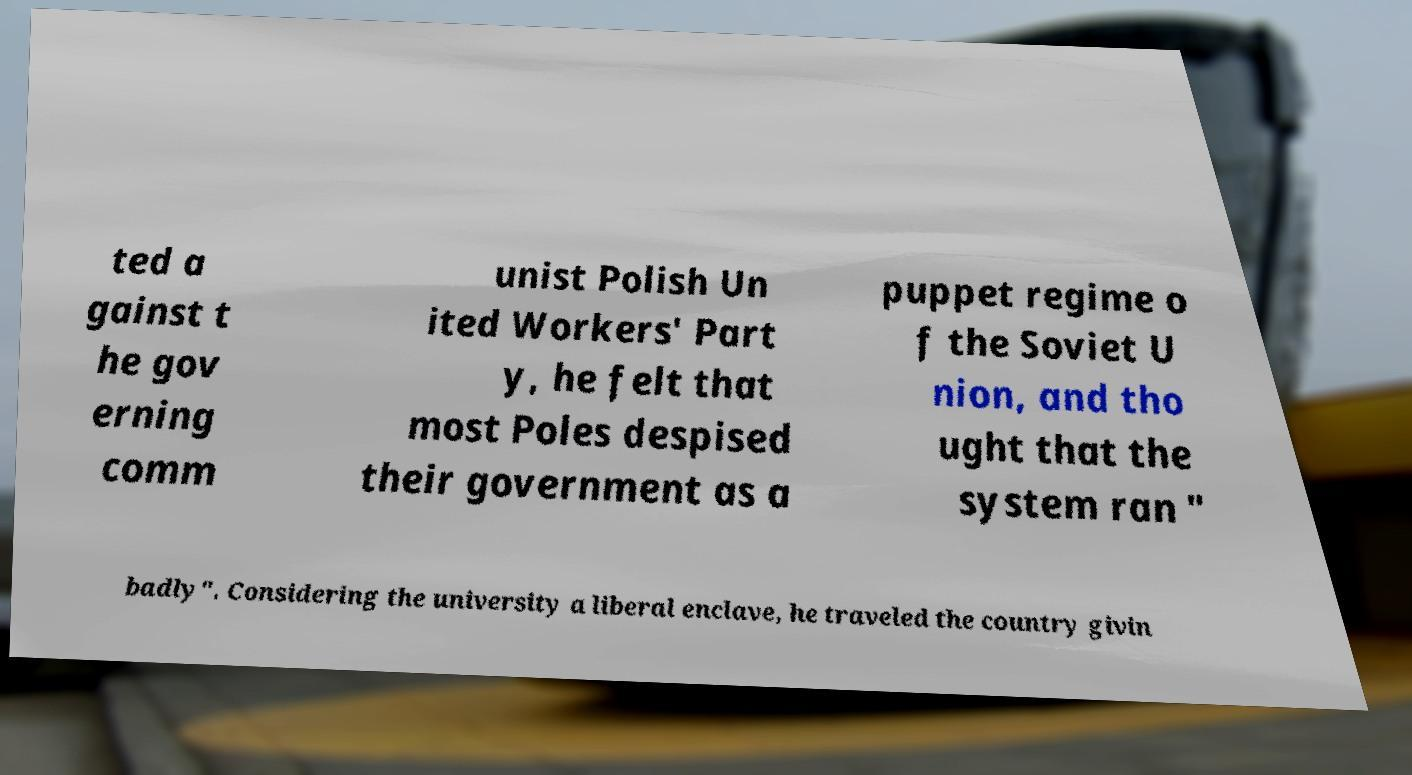There's text embedded in this image that I need extracted. Can you transcribe it verbatim? ted a gainst t he gov erning comm unist Polish Un ited Workers' Part y, he felt that most Poles despised their government as a puppet regime o f the Soviet U nion, and tho ught that the system ran " badly". Considering the university a liberal enclave, he traveled the country givin 